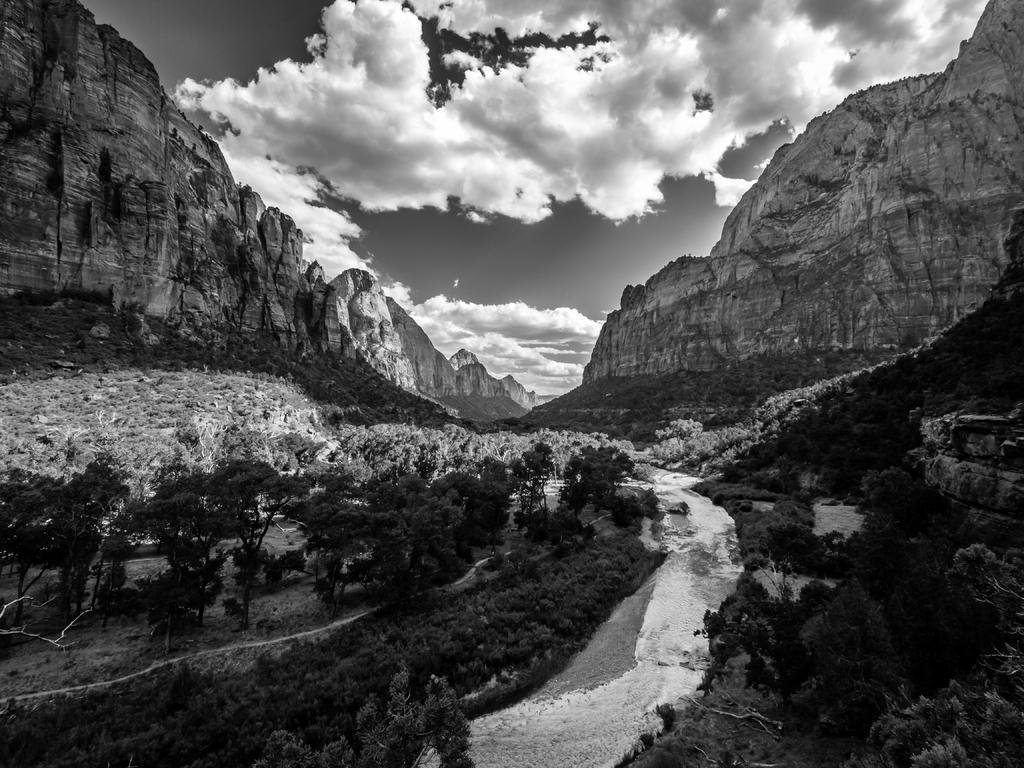In one or two sentences, can you explain what this image depicts? This is a black and white pic. Here we can see water is flowing on the ground in the middle. In the background there are trees,mountains and clouds in the sky. 